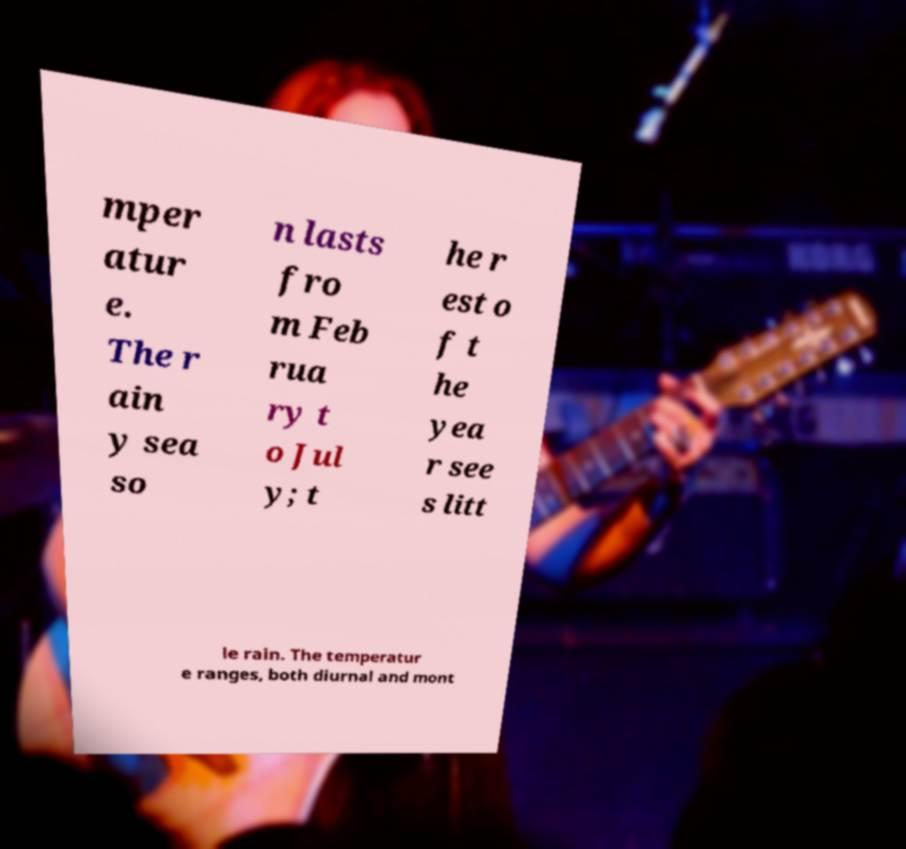For documentation purposes, I need the text within this image transcribed. Could you provide that? mper atur e. The r ain y sea so n lasts fro m Feb rua ry t o Jul y; t he r est o f t he yea r see s litt le rain. The temperatur e ranges, both diurnal and mont 